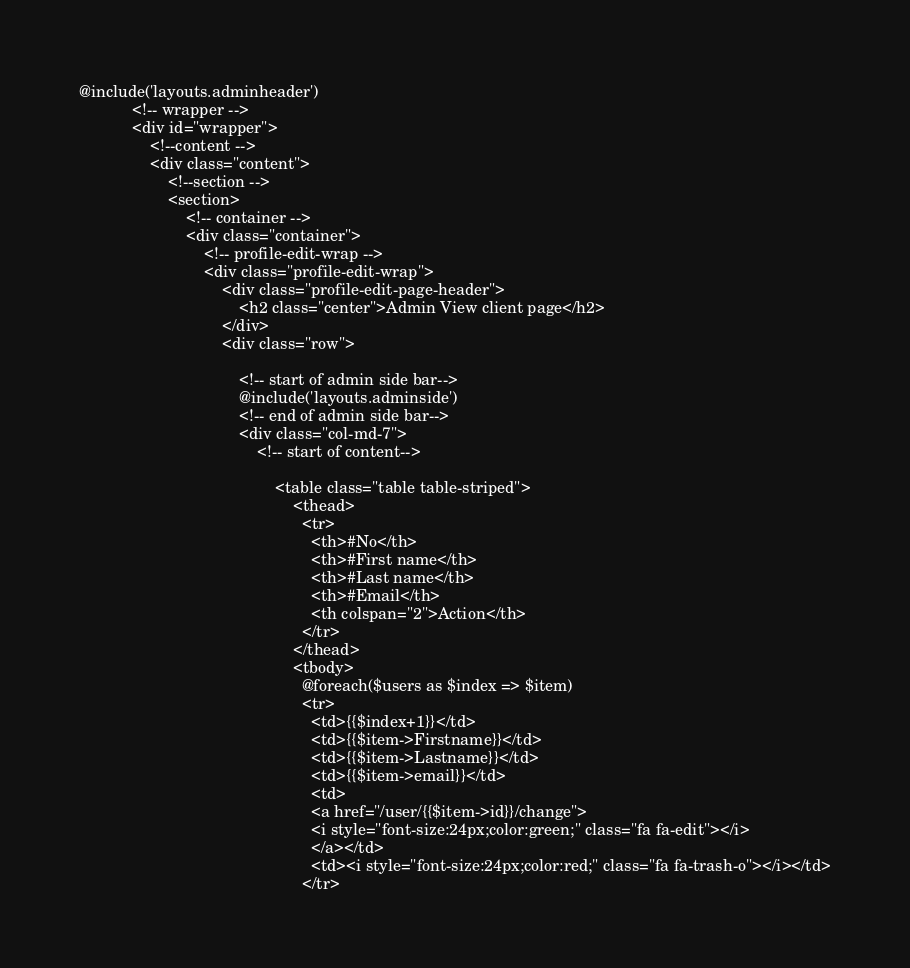Convert code to text. <code><loc_0><loc_0><loc_500><loc_500><_PHP_>@include('layouts.adminheader')	
            <!-- wrapper -->	
            <div id="wrapper"> 
                <!--content -->  
                <div class="content">
                    <!--section --> 
                    <section>
                        <!-- container -->
                        <div class="container">
                            <!-- profile-edit-wrap -->
                            <div class="profile-edit-wrap">
                                <div class="profile-edit-page-header">
                                    <h2 class="center">Admin View client page</h2>
                                </div>
                                <div class="row">

                                    <!-- start of admin side bar-->
                                    @include('layouts.adminside')
                                    <!-- end of admin side bar--> 
                                    <div class="col-md-7">
                                        <!-- start of content-->          

                                            <table class="table table-striped">
                                                <thead>
                                                  <tr>
                                                    <th>#No</th>
                                                    <th>#First name</th>
                                                    <th>#Last name</th>
                                                    <th>#Email</th>
                                                    <th colspan="2">Action</th>
                                                  </tr>
                                                </thead>
                                                <tbody>
                                                  @foreach($users as $index => $item)  
                                                  <tr>
                                                    <td>{{$index+1}}</td>
                                                    <td>{{$item->Firstname}}</td>
                                                    <td>{{$item->Lastname}}</td>
                                                    <td>{{$item->email}}</td>
                                                    <td>
                                                    <a href="/user/{{$item->id}}/change">
                                                    <i style="font-size:24px;color:green;" class="fa fa-edit"></i>
                                                    </a></td>
                                                    <td><i style="font-size:24px;color:red;" class="fa fa-trash-o"></i></td>
                                                  </tr></code> 